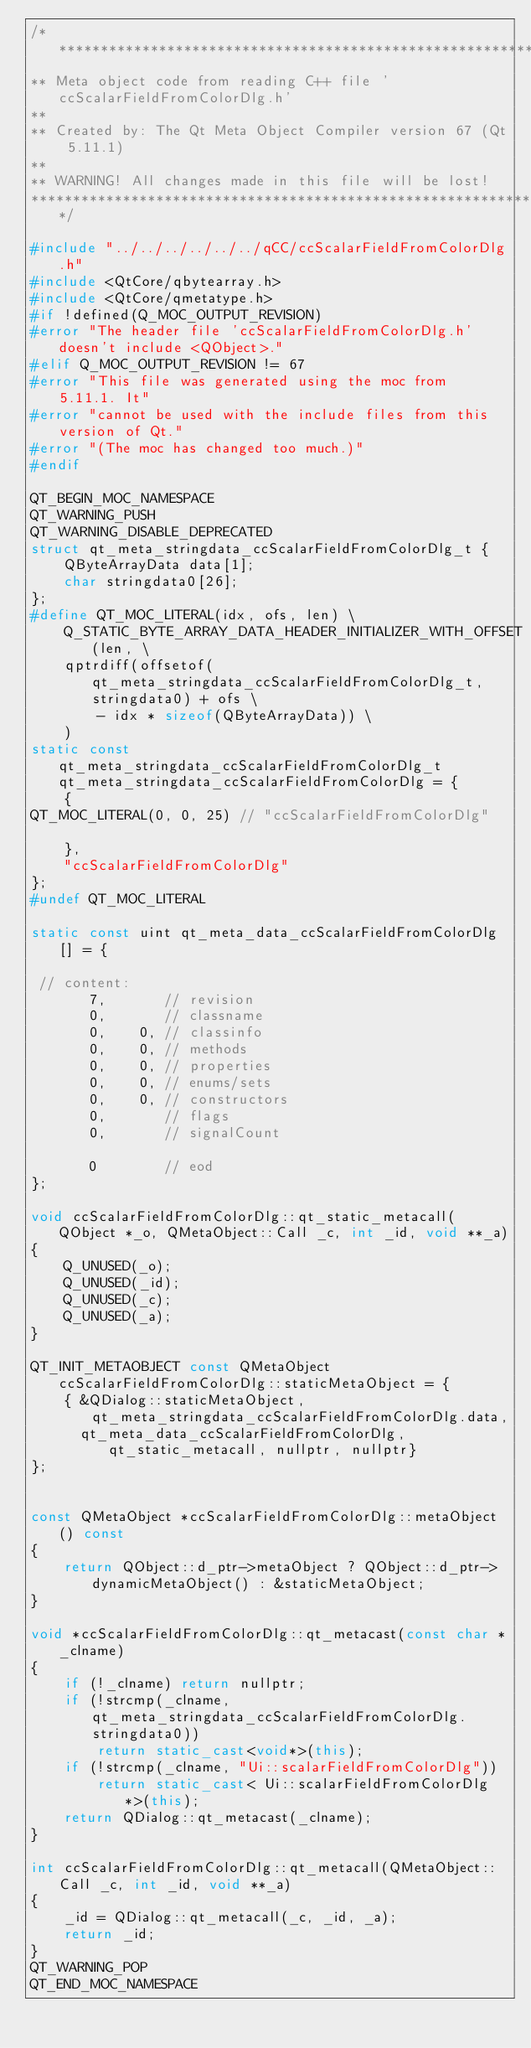<code> <loc_0><loc_0><loc_500><loc_500><_C++_>/****************************************************************************
** Meta object code from reading C++ file 'ccScalarFieldFromColorDlg.h'
**
** Created by: The Qt Meta Object Compiler version 67 (Qt 5.11.1)
**
** WARNING! All changes made in this file will be lost!
*****************************************************************************/

#include "../../../../../../qCC/ccScalarFieldFromColorDlg.h"
#include <QtCore/qbytearray.h>
#include <QtCore/qmetatype.h>
#if !defined(Q_MOC_OUTPUT_REVISION)
#error "The header file 'ccScalarFieldFromColorDlg.h' doesn't include <QObject>."
#elif Q_MOC_OUTPUT_REVISION != 67
#error "This file was generated using the moc from 5.11.1. It"
#error "cannot be used with the include files from this version of Qt."
#error "(The moc has changed too much.)"
#endif

QT_BEGIN_MOC_NAMESPACE
QT_WARNING_PUSH
QT_WARNING_DISABLE_DEPRECATED
struct qt_meta_stringdata_ccScalarFieldFromColorDlg_t {
    QByteArrayData data[1];
    char stringdata0[26];
};
#define QT_MOC_LITERAL(idx, ofs, len) \
    Q_STATIC_BYTE_ARRAY_DATA_HEADER_INITIALIZER_WITH_OFFSET(len, \
    qptrdiff(offsetof(qt_meta_stringdata_ccScalarFieldFromColorDlg_t, stringdata0) + ofs \
        - idx * sizeof(QByteArrayData)) \
    )
static const qt_meta_stringdata_ccScalarFieldFromColorDlg_t qt_meta_stringdata_ccScalarFieldFromColorDlg = {
    {
QT_MOC_LITERAL(0, 0, 25) // "ccScalarFieldFromColorDlg"

    },
    "ccScalarFieldFromColorDlg"
};
#undef QT_MOC_LITERAL

static const uint qt_meta_data_ccScalarFieldFromColorDlg[] = {

 // content:
       7,       // revision
       0,       // classname
       0,    0, // classinfo
       0,    0, // methods
       0,    0, // properties
       0,    0, // enums/sets
       0,    0, // constructors
       0,       // flags
       0,       // signalCount

       0        // eod
};

void ccScalarFieldFromColorDlg::qt_static_metacall(QObject *_o, QMetaObject::Call _c, int _id, void **_a)
{
    Q_UNUSED(_o);
    Q_UNUSED(_id);
    Q_UNUSED(_c);
    Q_UNUSED(_a);
}

QT_INIT_METAOBJECT const QMetaObject ccScalarFieldFromColorDlg::staticMetaObject = {
    { &QDialog::staticMetaObject, qt_meta_stringdata_ccScalarFieldFromColorDlg.data,
      qt_meta_data_ccScalarFieldFromColorDlg,  qt_static_metacall, nullptr, nullptr}
};


const QMetaObject *ccScalarFieldFromColorDlg::metaObject() const
{
    return QObject::d_ptr->metaObject ? QObject::d_ptr->dynamicMetaObject() : &staticMetaObject;
}

void *ccScalarFieldFromColorDlg::qt_metacast(const char *_clname)
{
    if (!_clname) return nullptr;
    if (!strcmp(_clname, qt_meta_stringdata_ccScalarFieldFromColorDlg.stringdata0))
        return static_cast<void*>(this);
    if (!strcmp(_clname, "Ui::scalarFieldFromColorDlg"))
        return static_cast< Ui::scalarFieldFromColorDlg*>(this);
    return QDialog::qt_metacast(_clname);
}

int ccScalarFieldFromColorDlg::qt_metacall(QMetaObject::Call _c, int _id, void **_a)
{
    _id = QDialog::qt_metacall(_c, _id, _a);
    return _id;
}
QT_WARNING_POP
QT_END_MOC_NAMESPACE
</code> 